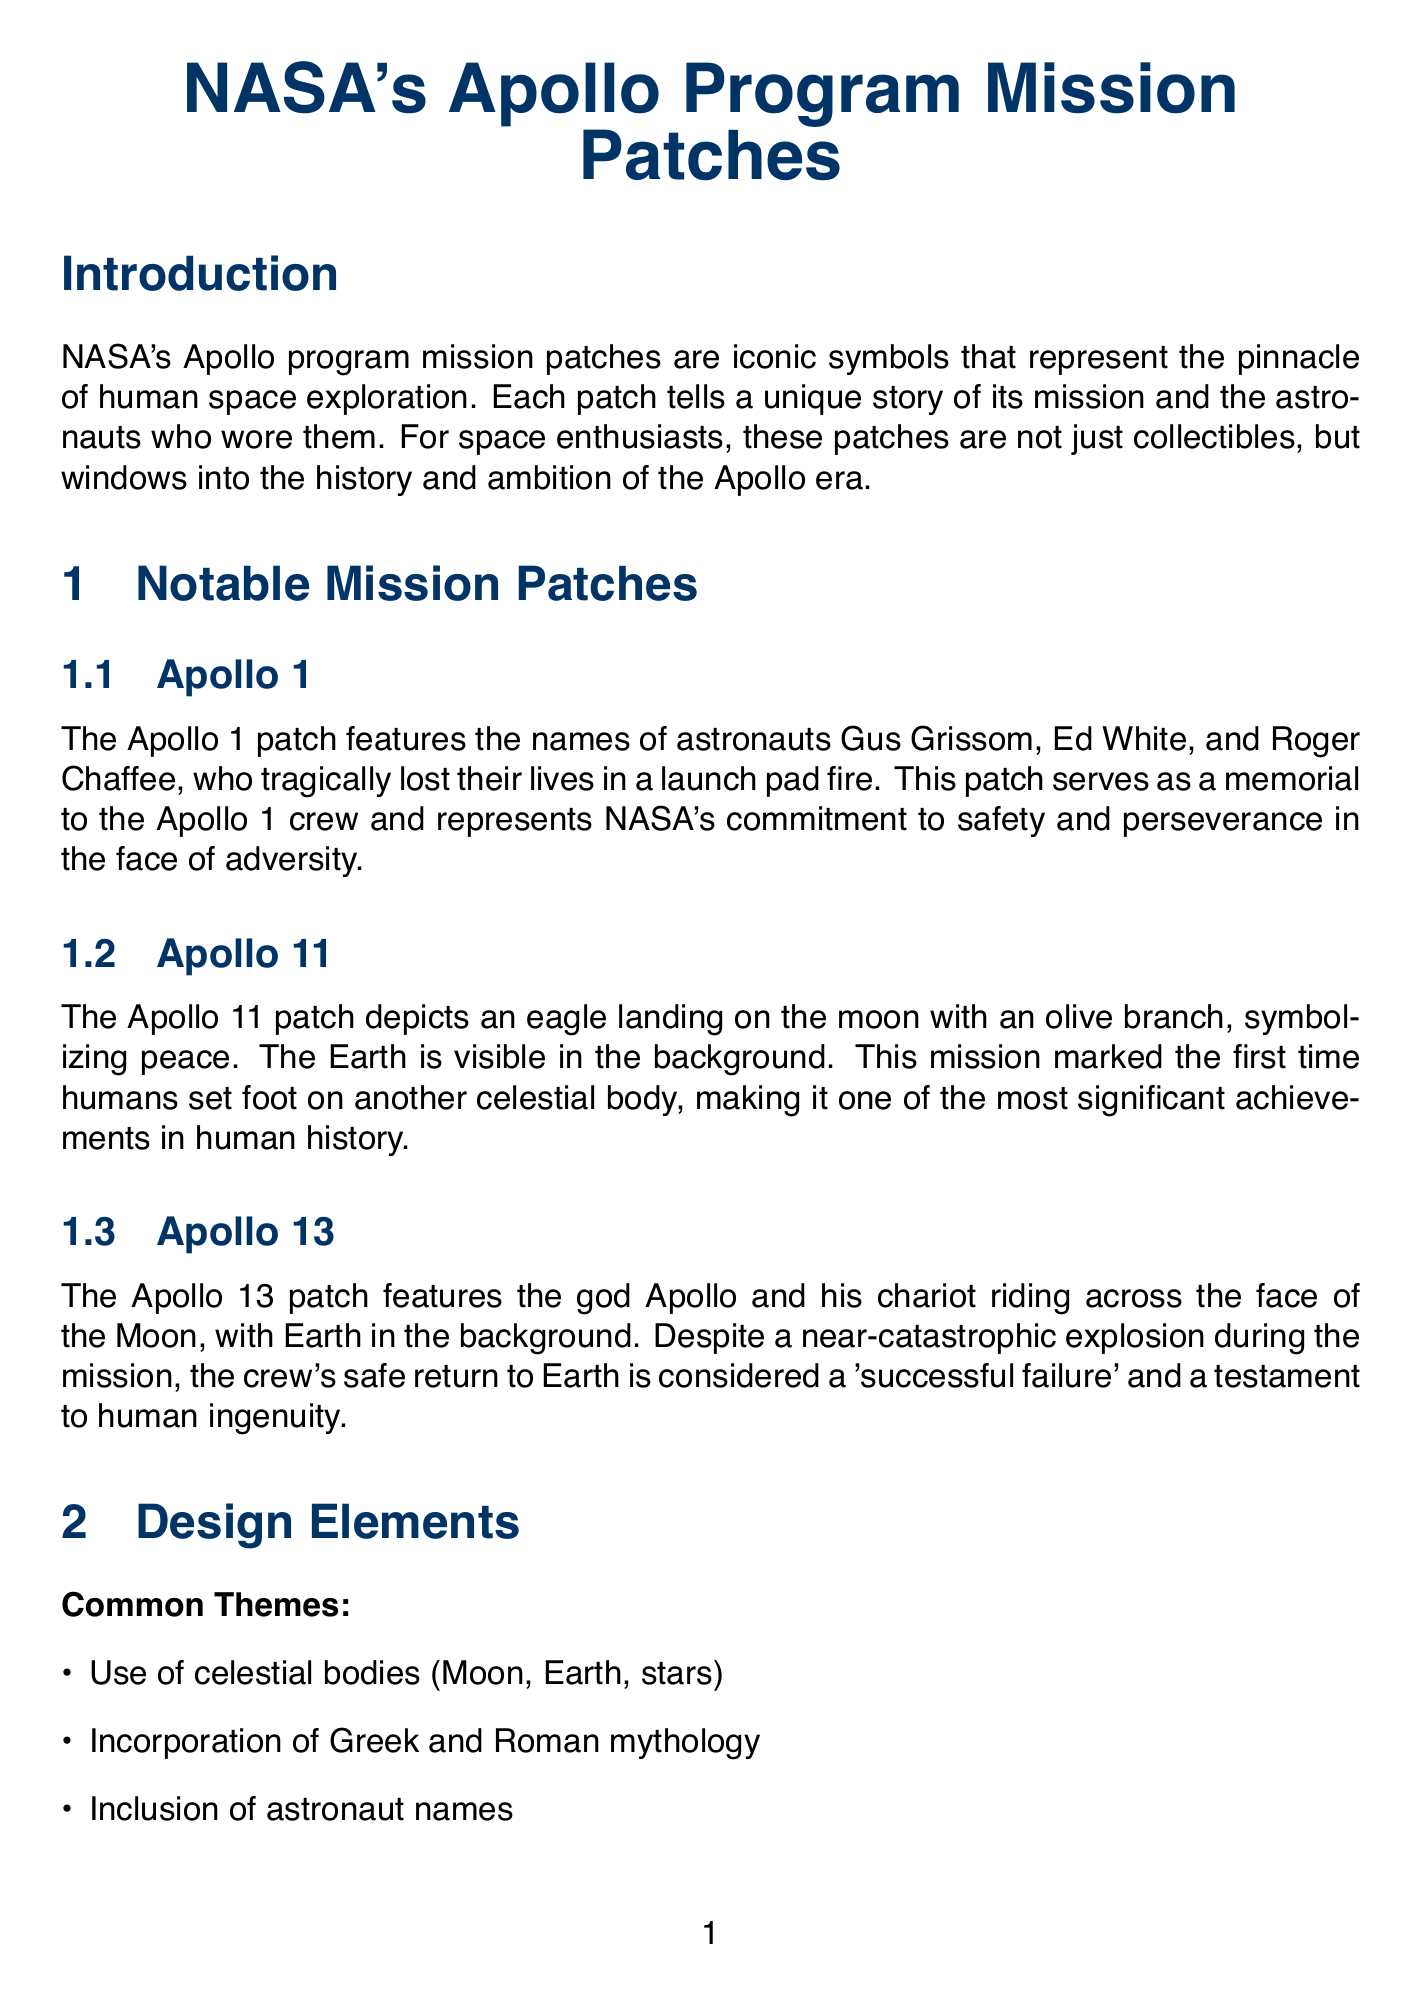What mission does the Apollo 1 patch commemorate? The Apollo 1 patch features the names of astronauts Gus Grissom, Ed White, and Roger Chaffee, who tragically lost their lives in a launch pad fire.
Answer: Apollo 1 What does the Apollo 11 patch symbolize? The Apollo 11 patch depicts an eagle landing on the moon with an olive branch, symbolizing peace.
Answer: Peace What is a common theme in NASA's mission patches? Common themes include the use of celestial bodies, incorporation of mythology, inclusion of astronaut names, and representations of mission objectives.
Answer: Celestial bodies How are original patches from the Apollo era described? Original Apollo-era patches worn by astronauts are extremely rare and valuable.
Answer: Rare and valuable What book is recommended for information about the Apollo missions? The document lists a book that includes detailed information about the Apollo missions.
Answer: To Rise from Earth: An Easy-to-Understand Guide to Spaceflight Which Apollo mission is referred to as a 'successful failure'? The Apollo 13 mission is considered a 'successful failure' due to the crew's safe return despite a near-catastrophic explosion.
Answer: Apollo 13 What colors predominantly feature in the design of the mission patches? Most patches use a combination of red, white, and blue.
Answer: Red, white, and blue Where can high-resolution images of NASA mission patches be found? The document states that images of mission patches can be found on the NASA History Division website.
Answer: NASA History Division 